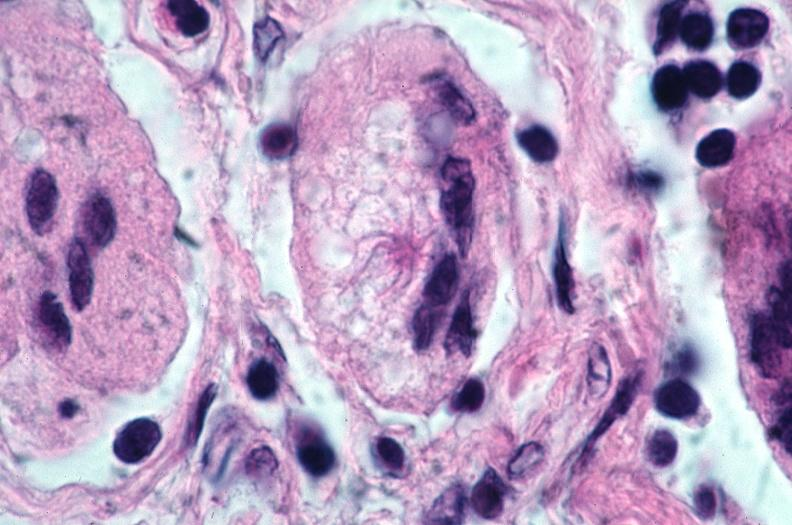what is present?
Answer the question using a single word or phrase. Respiratory 